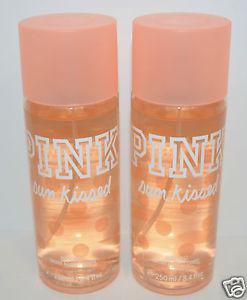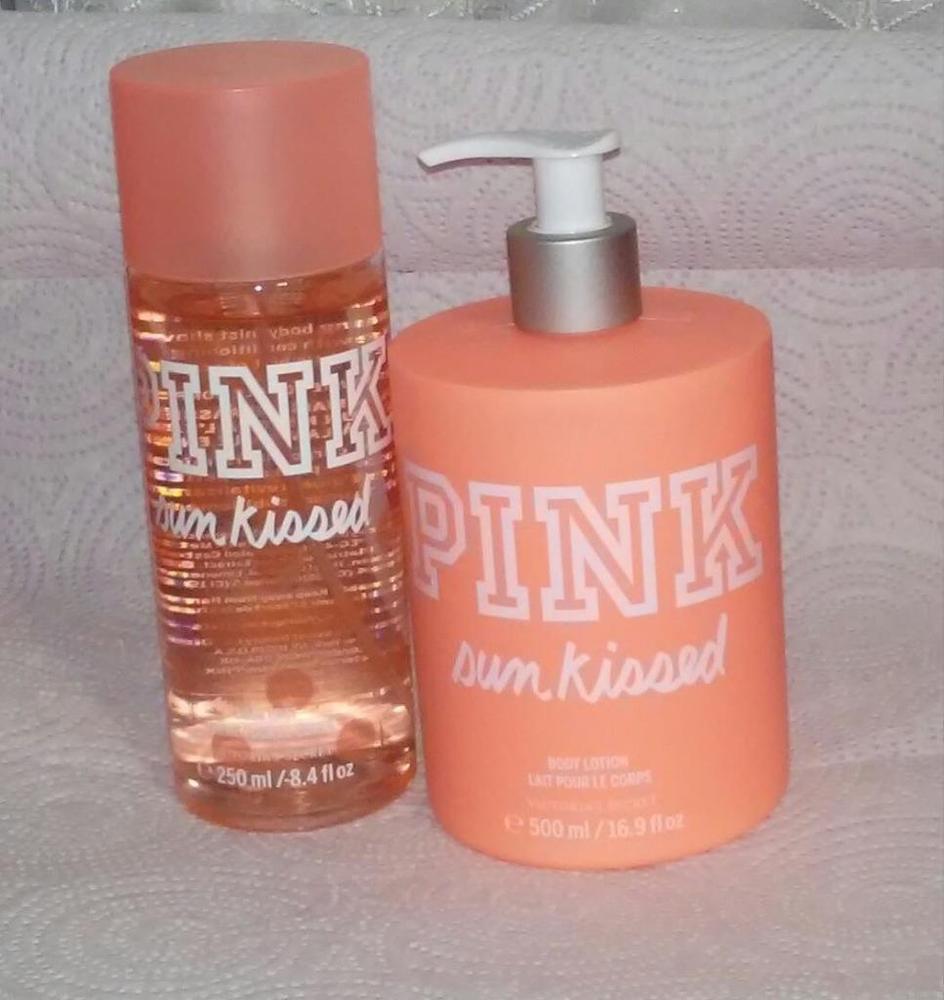The first image is the image on the left, the second image is the image on the right. Examine the images to the left and right. Is the description "Each image shows the same number of skincare products." accurate? Answer yes or no. Yes. 